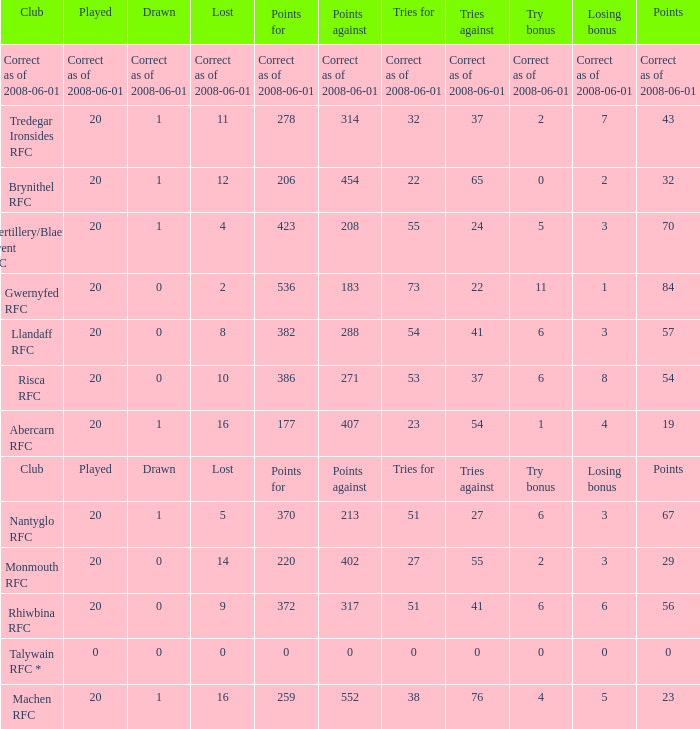If the points were 0, what were the tries for? 0.0. 